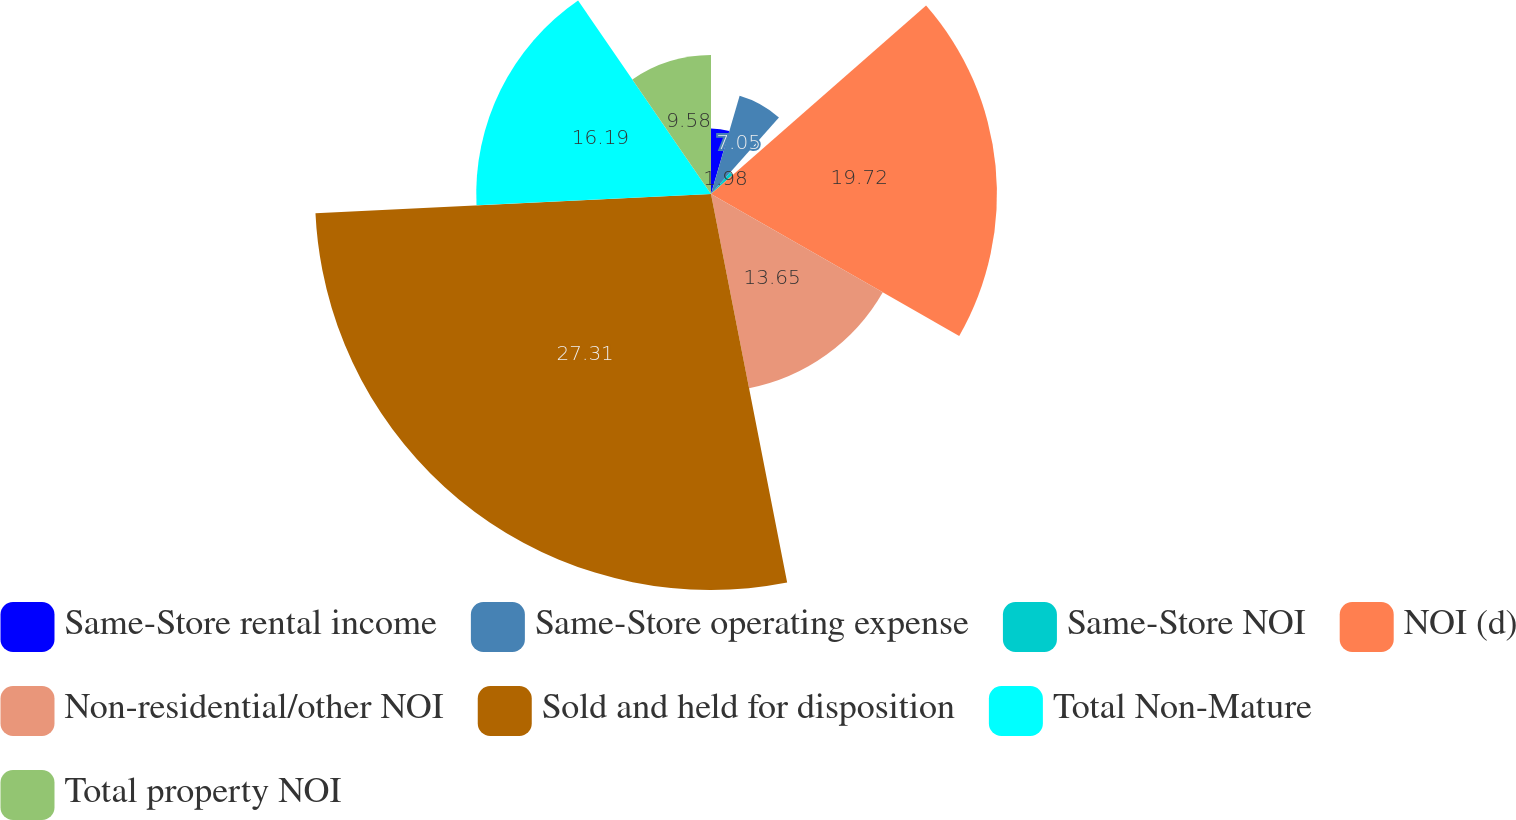Convert chart to OTSL. <chart><loc_0><loc_0><loc_500><loc_500><pie_chart><fcel>Same-Store rental income<fcel>Same-Store operating expense<fcel>Same-Store NOI<fcel>NOI (d)<fcel>Non-residential/other NOI<fcel>Sold and held for disposition<fcel>Total Non-Mature<fcel>Total property NOI<nl><fcel>4.52%<fcel>7.05%<fcel>1.98%<fcel>19.72%<fcel>13.65%<fcel>27.31%<fcel>16.19%<fcel>9.58%<nl></chart> 